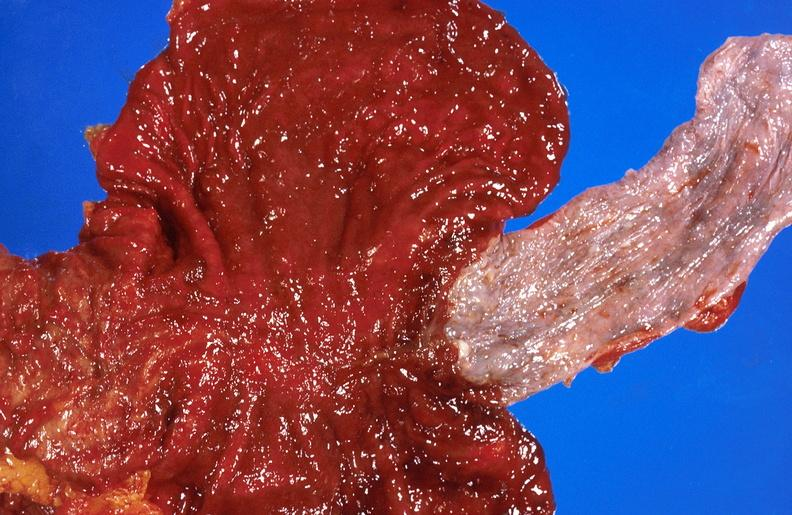s liver present?
Answer the question using a single word or phrase. Yes 